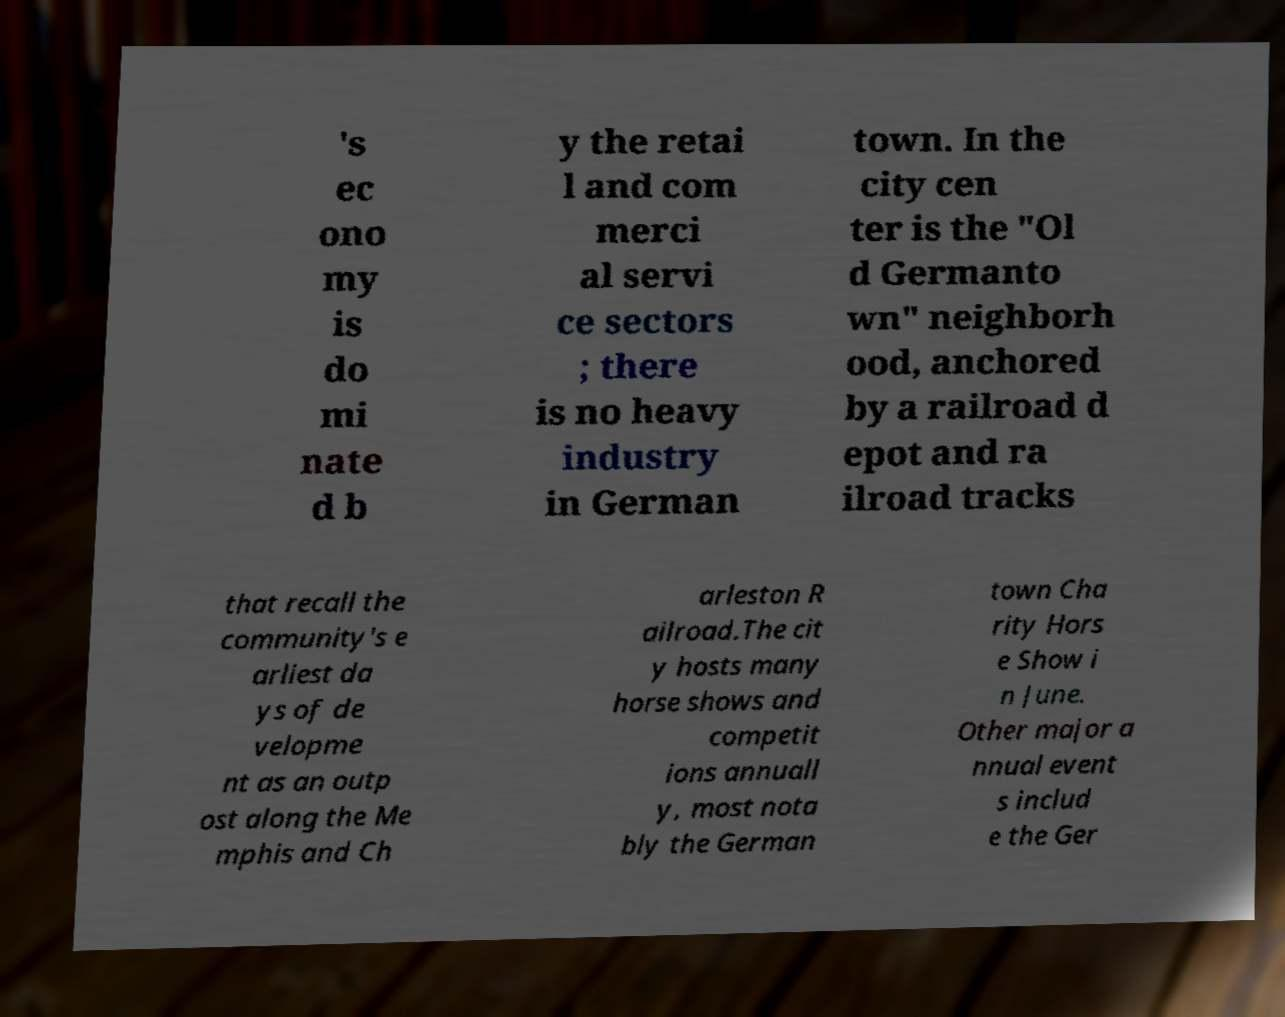For documentation purposes, I need the text within this image transcribed. Could you provide that? 's ec ono my is do mi nate d b y the retai l and com merci al servi ce sectors ; there is no heavy industry in German town. In the city cen ter is the "Ol d Germanto wn" neighborh ood, anchored by a railroad d epot and ra ilroad tracks that recall the community's e arliest da ys of de velopme nt as an outp ost along the Me mphis and Ch arleston R ailroad.The cit y hosts many horse shows and competit ions annuall y, most nota bly the German town Cha rity Hors e Show i n June. Other major a nnual event s includ e the Ger 